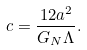Convert formula to latex. <formula><loc_0><loc_0><loc_500><loc_500>c = \frac { 1 2 a ^ { 2 } } { G _ { N } \Lambda } .</formula> 